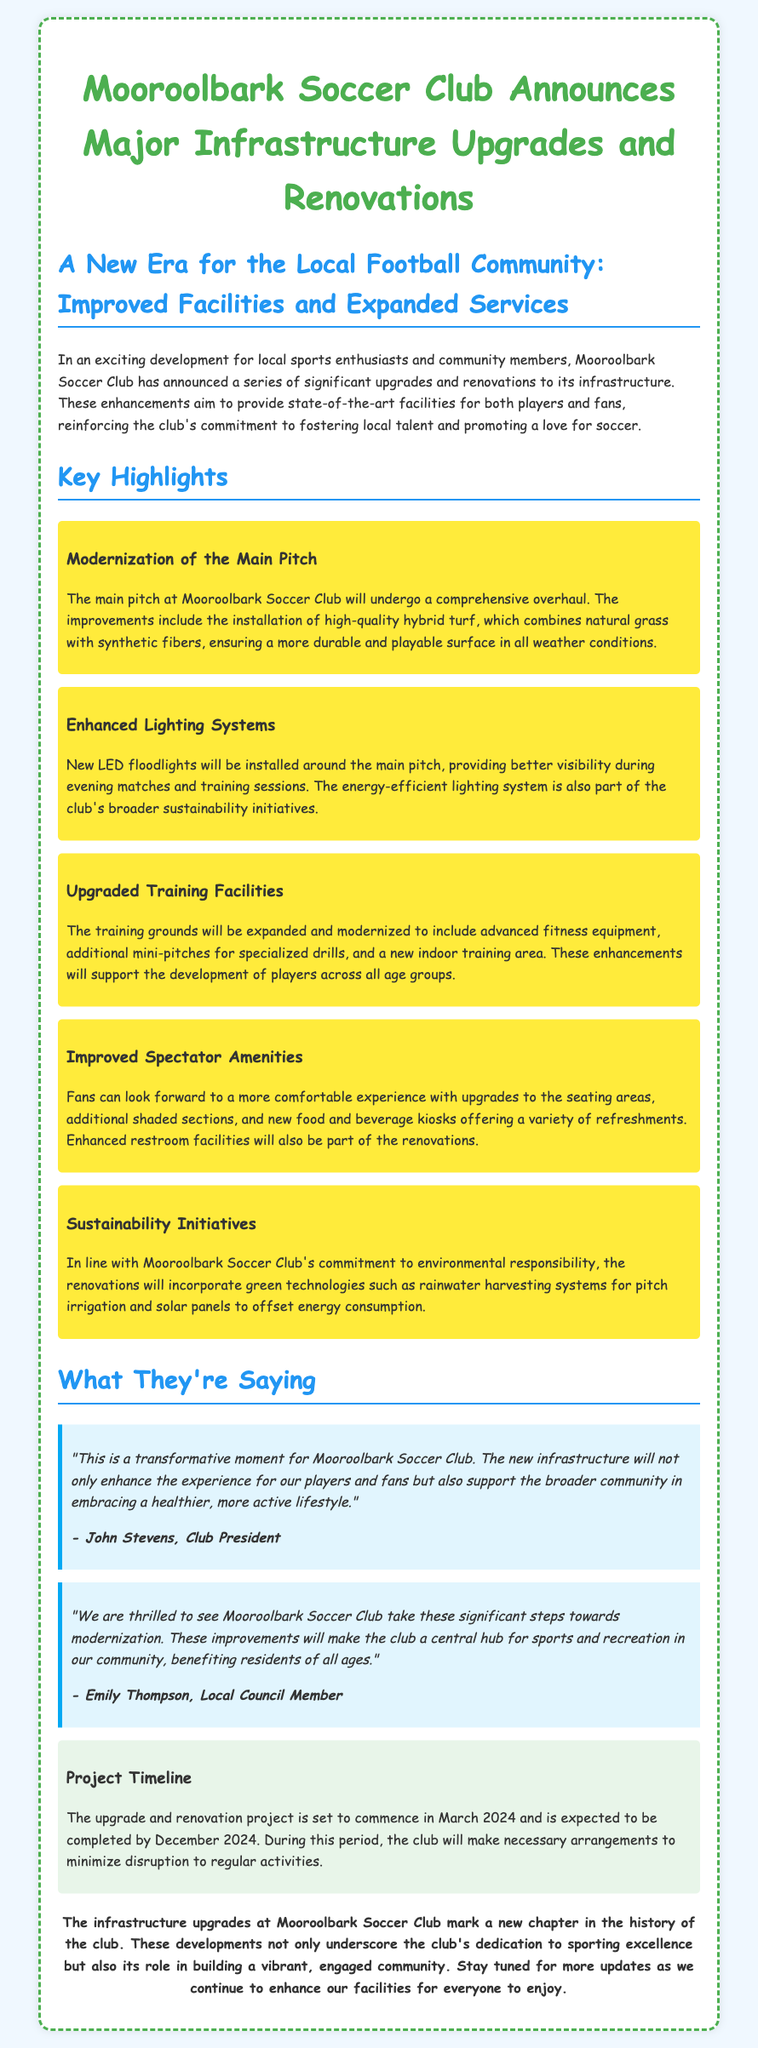What is being upgraded at Mooroolbark Soccer Club? The press release states that significant upgrades and renovations to infrastructure are planned, focusing on facilities for players and fans.
Answer: Infrastructure When will the project commence? According to the timeline section, the project is set to commence in March 2024.
Answer: March 2024 What type of turf will be installed on the main pitch? The main pitch will have hybrid turf installed, combining natural grass and synthetic fibers.
Answer: Hybrid turf Who is the Club President? The quoted statement is attributed to John Stevens, who is identified as the Club President.
Answer: John Stevens What kind of lighting system will be installed? The announcement mentions installing new LED floodlights around the main pitch.
Answer: LED floodlights What is one of the sustainability initiatives mentioned? The club plans to incorporate rainwater harvesting systems for pitch irrigation as part of its sustainability initiatives.
Answer: Rainwater harvesting systems How long is the project expected to take? The completion date provided indicates that the project is expected to be completed by December 2024, suggesting a duration of approximately nine months.
Answer: Nine months What did Emily Thompson, a local council member, say about the renovations? Emily Thompson expressed her excitement about the significant modernization steps being taken by the club.
Answer: Significant modernization steps What improvements will fans experience? Fans can look forward to a more comfortable experience with upgrades to seating areas, shaded sections, and food kiosks.
Answer: Comfortable experience 